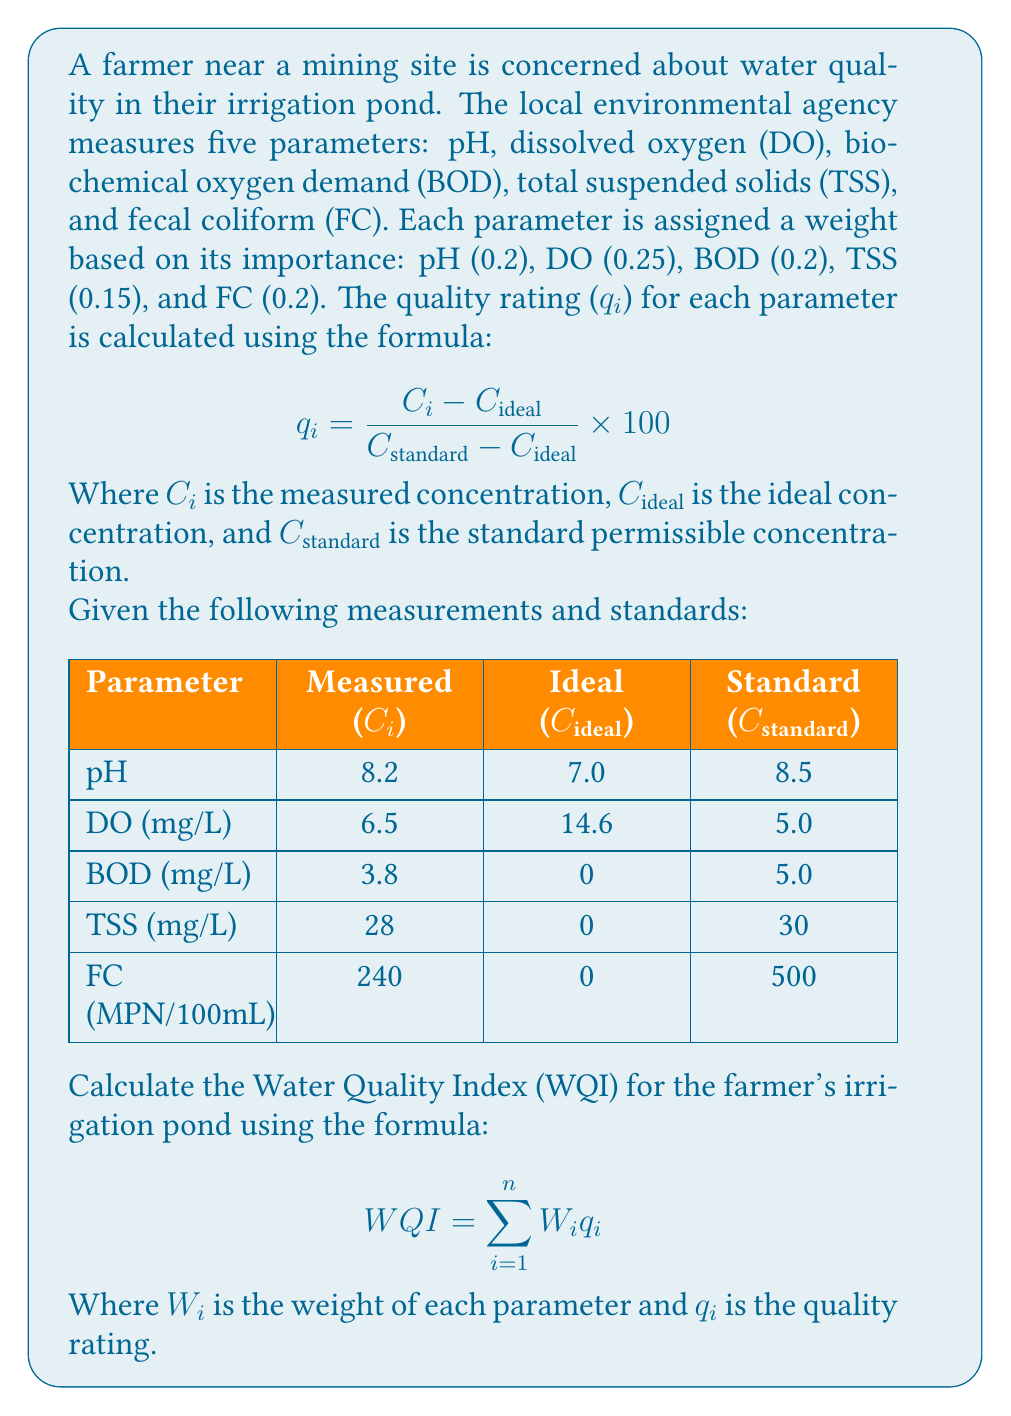What is the answer to this math problem? To solve this problem, we need to follow these steps:

1. Calculate the quality rating ($q_i$) for each parameter using the given formula.
2. Multiply each quality rating by its corresponding weight ($W_i$).
3. Sum up all the weighted quality ratings to get the final WQI.

Let's calculate the quality rating for each parameter:

1. pH:
$$ q_{pH} = \frac{8.2 - 7.0}{8.5 - 7.0} \times 100 = 80 $$

2. Dissolved Oxygen (DO):
$$ q_{DO} = \frac{6.5 - 14.6}{5.0 - 14.6} \times 100 = 84.38 $$

3. Biochemical Oxygen Demand (BOD):
$$ q_{BOD} = \frac{3.8 - 0}{5.0 - 0} \times 100 = 76 $$

4. Total Suspended Solids (TSS):
$$ q_{TSS} = \frac{28 - 0}{30 - 0} \times 100 = 93.33 $$

5. Fecal Coliform (FC):
$$ q_{FC} = \frac{240 - 0}{500 - 0} \times 100 = 48 $$

Now, let's multiply each quality rating by its weight and sum them up:

$$ WQI = (0.2 \times 80) + (0.25 \times 84.38) + (0.2 \times 76) + (0.15 \times 93.33) + (0.2 \times 48) $$
$$ WQI = 16 + 21.095 + 15.2 + 14 + 9.6 $$
$$ WQI = 75.895 $$
Answer: The Water Quality Index (WQI) for the farmer's irrigation pond is 75.895. 